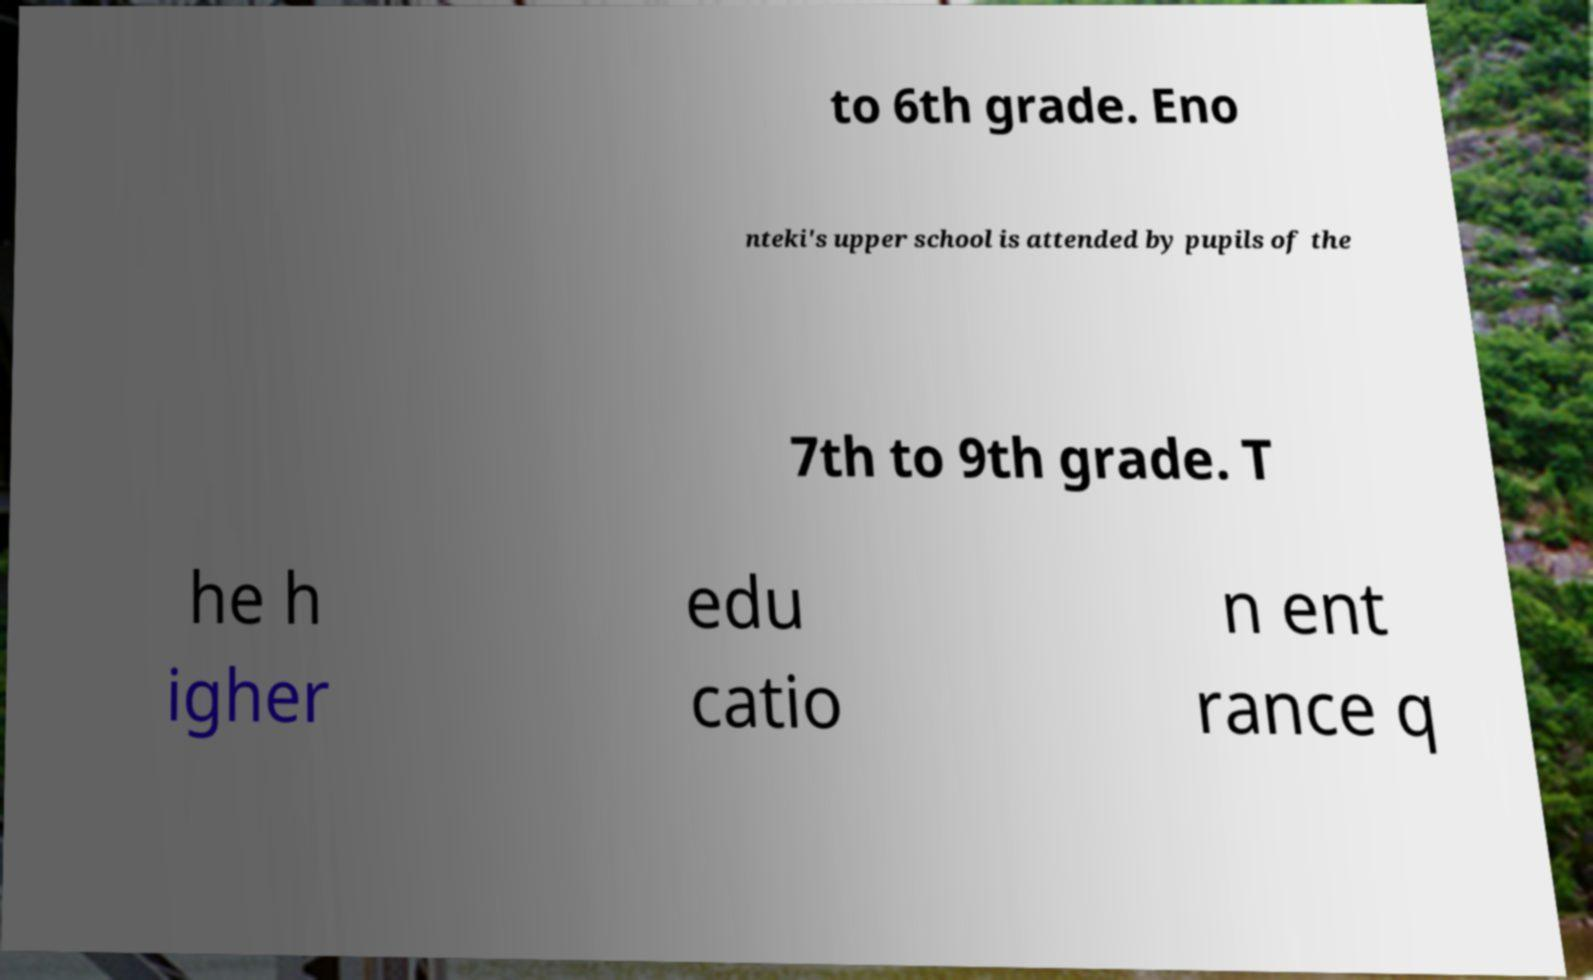Can you read and provide the text displayed in the image?This photo seems to have some interesting text. Can you extract and type it out for me? to 6th grade. Eno nteki's upper school is attended by pupils of the 7th to 9th grade. T he h igher edu catio n ent rance q 